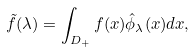<formula> <loc_0><loc_0><loc_500><loc_500>\tilde { f } ( \lambda ) = \int _ { D _ { + } } f ( x ) \hat { \phi } _ { \lambda } ( x ) d x ,</formula> 